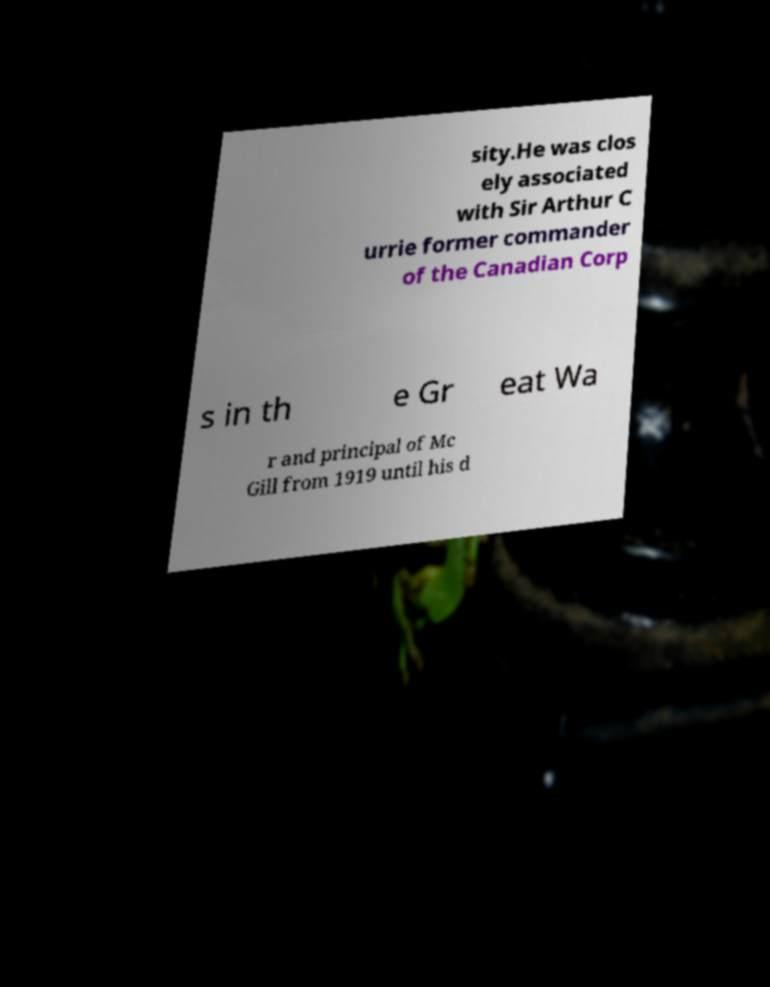Can you accurately transcribe the text from the provided image for me? sity.He was clos ely associated with Sir Arthur C urrie former commander of the Canadian Corp s in th e Gr eat Wa r and principal of Mc Gill from 1919 until his d 